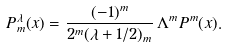<formula> <loc_0><loc_0><loc_500><loc_500>P _ { m } ^ { \lambda } ( x ) = \frac { ( - 1 ) ^ { m } } { 2 ^ { m } ( \lambda + 1 / 2 ) _ { m } } \, \Lambda ^ { m } P ^ { m } ( x ) .</formula> 